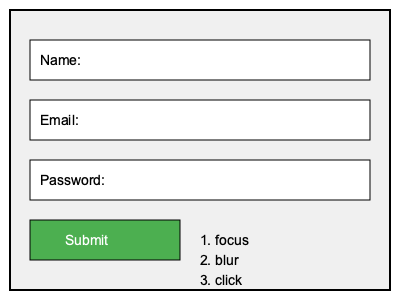Match the appropriate JavaScript event listeners to the UI elements in the web form shown above. Which event listener should be used for the "Submit" button? To determine the appropriate event listener for the "Submit" button, let's consider the purpose of each event listener and the functionality of the button:

1. focus: This event is triggered when an element receives focus, typically used for input fields when a user clicks or tabs into them.

2. blur: This event occurs when an element loses focus, often used to validate input fields when a user moves away from them.

3. click: This event is fired when an element is clicked, commonly used for buttons to trigger actions.

The "Submit" button in a web form is designed to be clicked by the user to send the form data. When a user interacts with a button, they typically click on it rather than focusing or blurring it.

Therefore, the most appropriate event listener for the "Submit" button would be the "click" event. This allows you to capture the user's intention to submit the form and execute the necessary JavaScript code to handle the form submission process.
Answer: click 